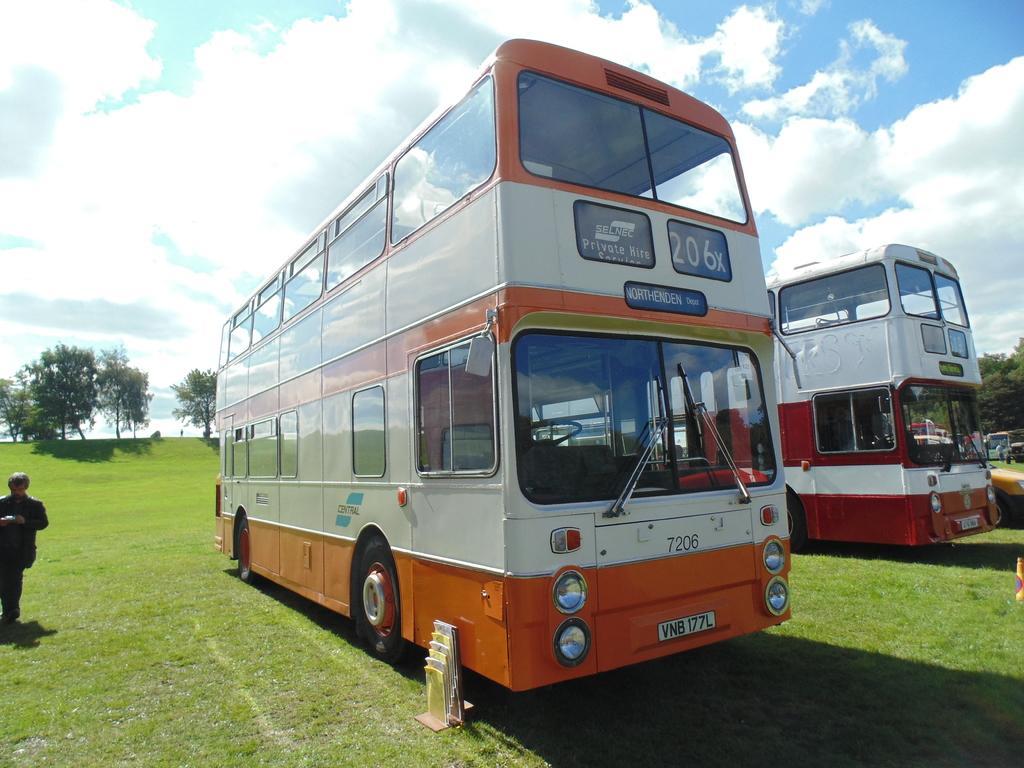How would you summarize this image in a sentence or two? In this picture there is a white and red color two double Decker buses parked in the grassland. Behind there are some trees and on the left corner there is a man wearing black color suit is standing. 